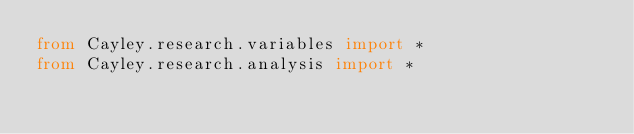Convert code to text. <code><loc_0><loc_0><loc_500><loc_500><_Python_>from Cayley.research.variables import *
from Cayley.research.analysis import *
</code> 